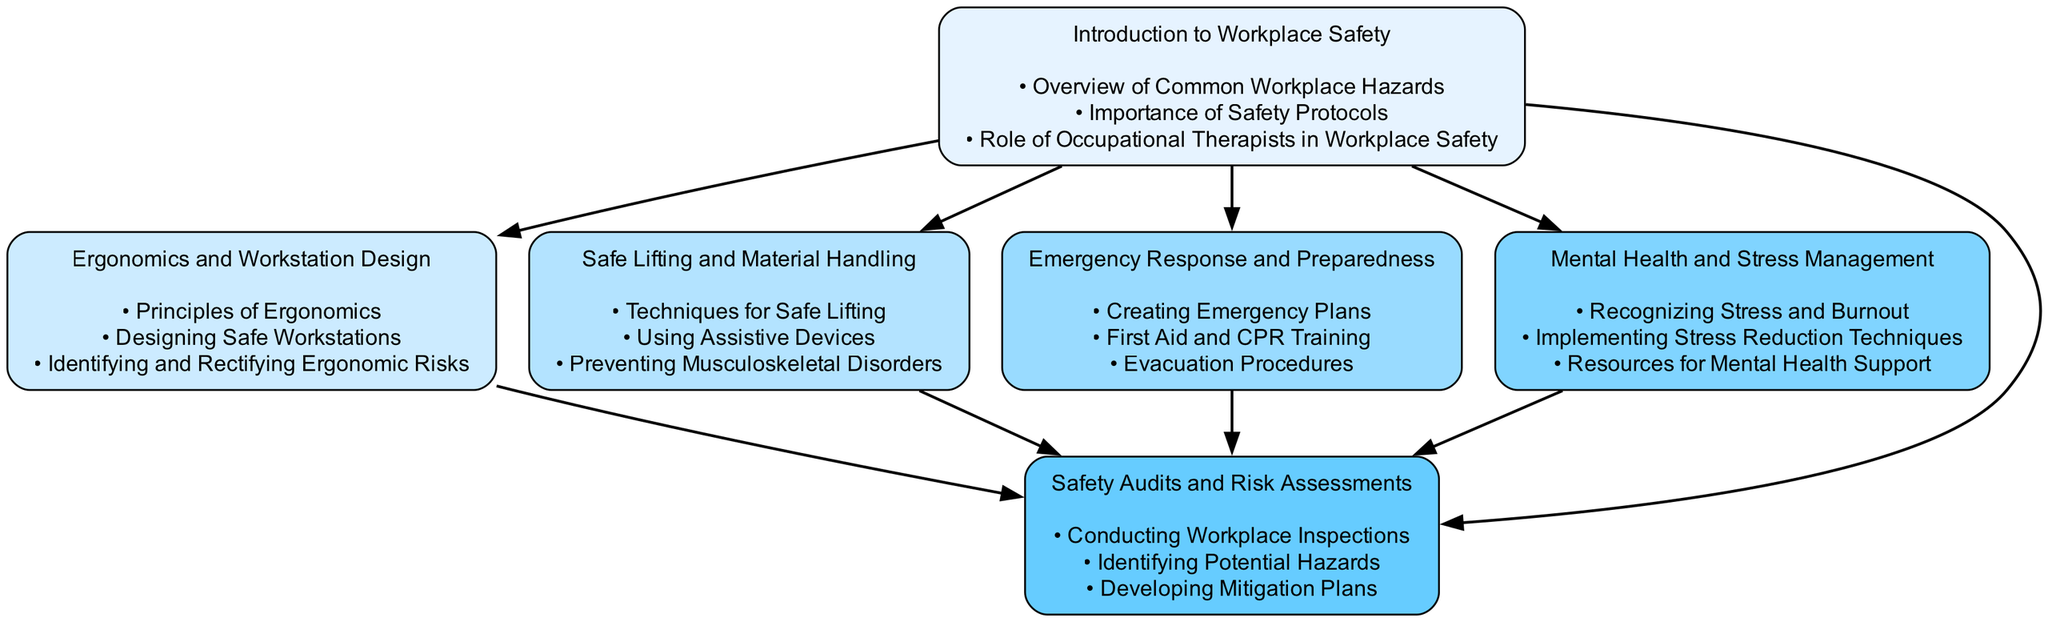What is the first module in the training progression? The first module can be identified at the top of the diagram as it has no dependencies. It is called "Introduction to Workplace Safety."
Answer: Introduction to Workplace Safety How many modules depend on "Introduction to Workplace Safety"? By analyzing the dependencies indicated for other modules, it's evident that four modules rely on "Introduction to Workplace Safety," as they are all listed under its dependencies.
Answer: 4 What are the contents of the "Emergency Response and Preparedness" module? The contents can be found by locating the module and examining the list presented below it. The contents include "Creating Emergency Plans," "First Aid and CPR Training," and "Evacuation Procedures."
Answer: Creating Emergency Plans, First Aid and CPR Training, Evacuation Procedures Which module includes both "Safe Lifting and Material Handling" and "Mental Health and Stress Management" as dependencies? Looking for a module that requires both of these specific dependencies leads us to "Safety Audits and Risk Assessments," as it's the only module that lists all other modules in its dependencies section.
Answer: Safety Audits and Risk Assessments How many total modules are present in the diagram? Counting the boxes or nodes in the diagram reveals a total of six distinct training modules.
Answer: 6 What is the last module in the training sequence based on the diagram? The last module can be determined by examining the ordering and dependency implications; "Safety Audits and Risk Assessments" is the last, as all others lead into it.
Answer: Safety Audits and Risk Assessments What dependency do modules "Ergonomics and Workstation Design" and "Safe Lifting and Material Handling" share? Both modules have a common dependency, which is "Introduction to Workplace Safety," as indicated by their individual dependency lists showing it as a requirement.
Answer: Introduction to Workplace Safety Which module is directly dependent on "Safe Lifting and Material Handling"? By analyzing the dependencies of all modules, it becomes clear that "Safety Audits and Risk Assessments" is the module that includes "Safe Lifting and Material Handling" as one of its prerequisites.
Answer: Safety Audits and Risk Assessments Which training module has the highest number of dependencies? Analyzing the modules, we find that "Safety Audits and Risk Assessments" has the highest number of dependencies, specifically five modules leading into it.
Answer: Safety Audits and Risk Assessments 